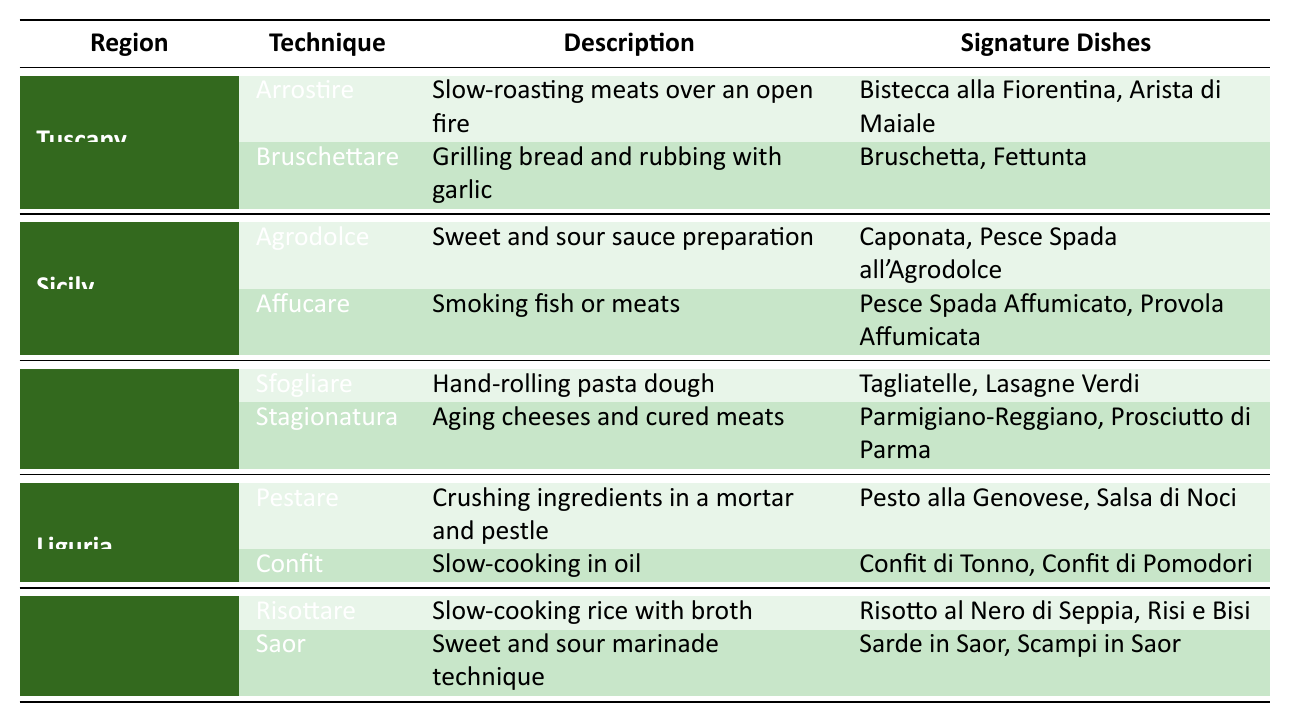What is the cooking technique used in Tuscany that involves slow-roasting meats? The table lists "Arrostire" as the cooking technique for Tuscany, which is described as slow-roasting meats over an open fire.
Answer: Arrostire Which signature dish from Sicily is made with a sweet and sour sauce? The table indicates that "Caponata" is a signature dish from Sicily, linked to the "Agrodolce" technique, which is focused on sweet and sour sauce preparation.
Answer: Caponata How many cooking techniques are listed for Emilia-Romagna? The table shows that there are 2 cooking techniques listed for Emilia-Romagna: "Sfogliare" and "Stagionatura." Thus, the total count is 2.
Answer: 2 Which region features the technique of "Pestare"? According to the table, "Pestare" is the cooking technique associated with Liguria.
Answer: Liguria What two regions have techniques involving the preparation of sweet and sour dishes? Both Sicily (with "Agrodolce") and Veneto (with "Saor") feature techniques for preparing sweet and sour dishes, as shown in their respective sections of the table.
Answer: Sicily and Veneto Is there a technique listed for Liguria that involves slow-cooking? The table indicates that "Confit" in Liguria is a technique that involves slow-cooking in oil, thus confirming the presence of this cooking method.
Answer: Yes What are the signature dishes associated with the "Risottare" technique in Veneto? The table shows that the signature dishes associated with "Risottare" in Veneto are "Risotto al Nero di Seppia" and "Risi e Bisi," clearly stated in the corresponding section.
Answer: Risotto al Nero di Seppia, Risi e Bisi If you combine the number of techniques from Tuscany and Liguria, what is the total? Tuscany has 2 techniques ("Arrostire" and "Bruschettare"), and Liguria also has 2 techniques ("Pestare" and "Confit"), totaling 4 techniques when combined.
Answer: 4 What is the primary method used in Emilia-Romagna for dough preparation? The table specifies "Sfogliare" as the primary method used in Emilia-Romagna for hand-rolling pasta dough, which emphasizes its importance in the region's culinary practices.
Answer: Sfogliare Are there any cooking techniques related to cheese in the table? Yes, the table mentions "Stagionatura" in Emilia-Romagna, which focuses on aging cheeses and cured meats, making it a technique related to cheese preparation.
Answer: Yes 